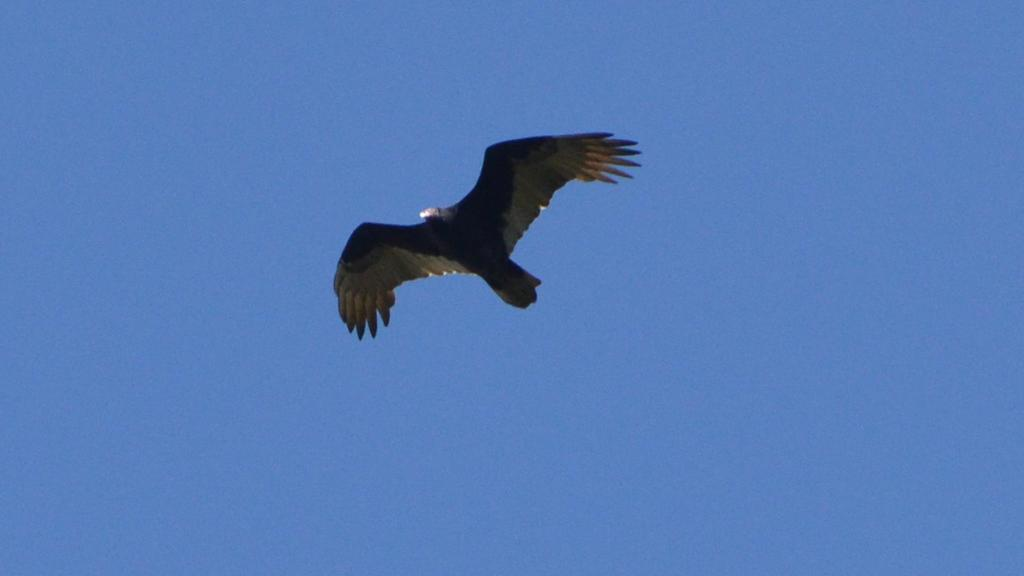What type of animal can be seen in the image? There is a bird in the image. What is the bird doing in the image? The bird is flying. What color is the sky in the image? The sky is blue in the image. What type of punishment is being given to the person in the image? There is no person present in the image, and therefore no punishment can be observed. 